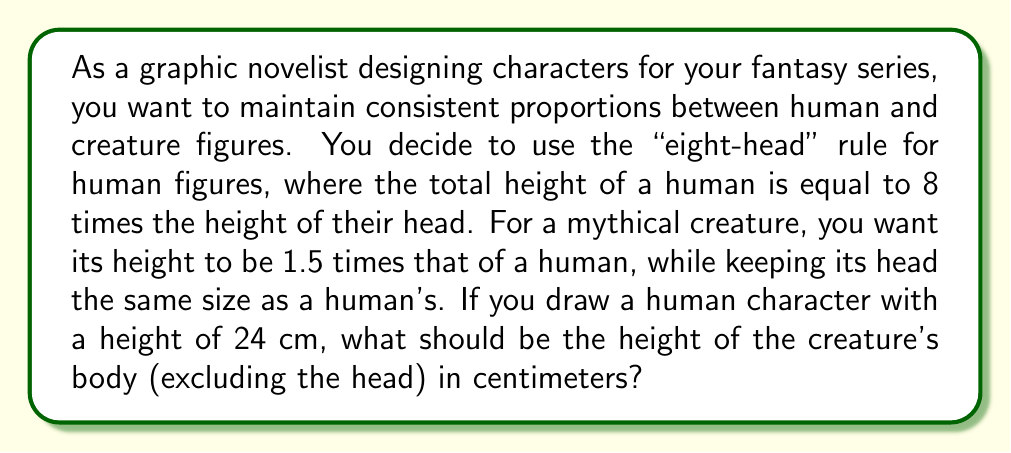Can you answer this question? Let's approach this step-by-step:

1) First, we need to determine the size of the human head:
   - Human height = 24 cm
   - Human height = 8 × head height
   - $24 = 8h$, where $h$ is the head height
   - $h = 24 \div 8 = 3$ cm

2) Now, we know the creature's head will be the same size: 3 cm

3) The creature's total height should be 1.5 times the human's height:
   - Creature height = $1.5 \times 24 = 36$ cm

4) To find the height of the creature's body, we subtract the head height:
   - Creature body height = Total height - Head height
   - Creature body height = $36 - 3 = 33$ cm

Therefore, the height of the creature's body (excluding the head) should be 33 cm.
Answer: 33 cm 